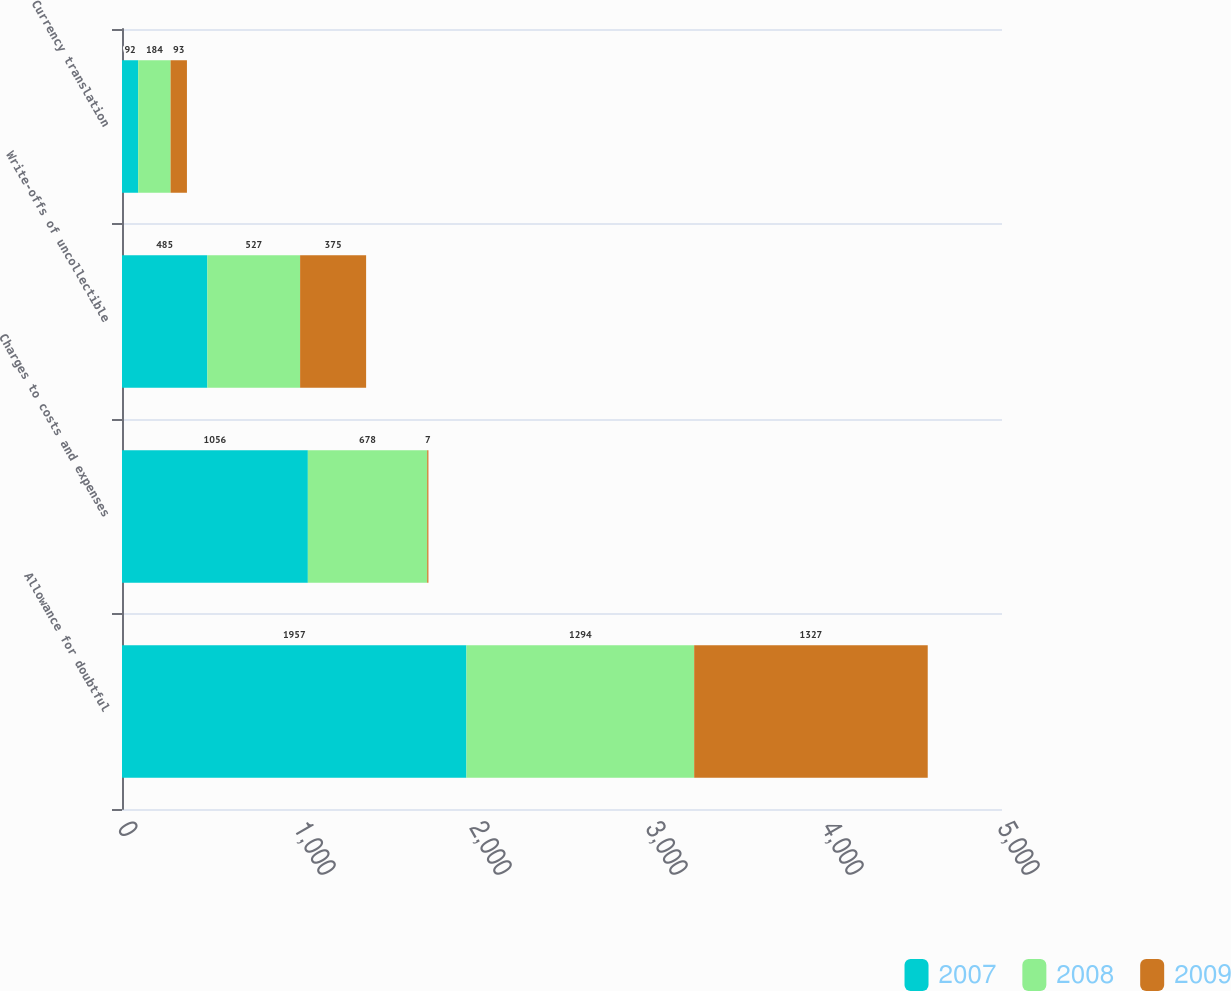Convert chart to OTSL. <chart><loc_0><loc_0><loc_500><loc_500><stacked_bar_chart><ecel><fcel>Allowance for doubtful<fcel>Charges to costs and expenses<fcel>Write-offs of uncollectible<fcel>Currency translation<nl><fcel>2007<fcel>1957<fcel>1056<fcel>485<fcel>92<nl><fcel>2008<fcel>1294<fcel>678<fcel>527<fcel>184<nl><fcel>2009<fcel>1327<fcel>7<fcel>375<fcel>93<nl></chart> 